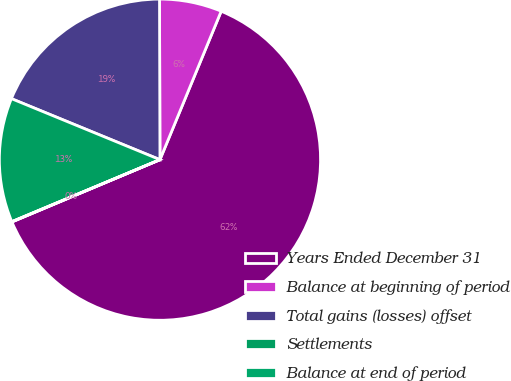Convert chart. <chart><loc_0><loc_0><loc_500><loc_500><pie_chart><fcel>Years Ended December 31<fcel>Balance at beginning of period<fcel>Total gains (losses) offset<fcel>Settlements<fcel>Balance at end of period<nl><fcel>62.43%<fcel>6.27%<fcel>18.75%<fcel>12.51%<fcel>0.03%<nl></chart> 